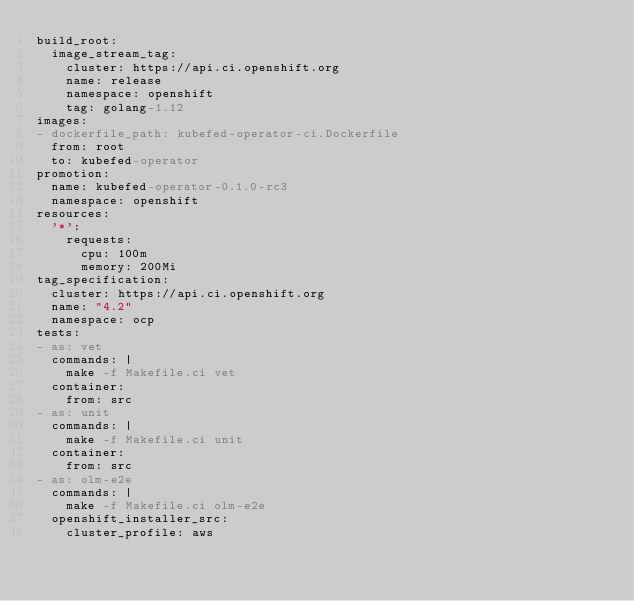Convert code to text. <code><loc_0><loc_0><loc_500><loc_500><_YAML_>build_root:
  image_stream_tag:
    cluster: https://api.ci.openshift.org
    name: release
    namespace: openshift
    tag: golang-1.12
images:
- dockerfile_path: kubefed-operator-ci.Dockerfile
  from: root
  to: kubefed-operator
promotion:
  name: kubefed-operator-0.1.0-rc3
  namespace: openshift
resources:
  '*':
    requests:
      cpu: 100m
      memory: 200Mi
tag_specification:
  cluster: https://api.ci.openshift.org
  name: "4.2"
  namespace: ocp
tests:
- as: vet
  commands: |
    make -f Makefile.ci vet
  container:
    from: src
- as: unit
  commands: |
    make -f Makefile.ci unit
  container:
    from: src
- as: olm-e2e
  commands: |
    make -f Makefile.ci olm-e2e
  openshift_installer_src:
    cluster_profile: aws
</code> 